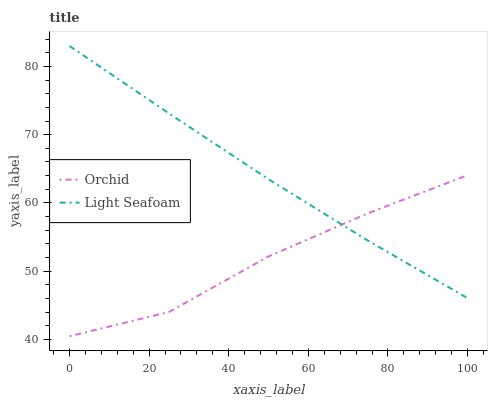Does Orchid have the minimum area under the curve?
Answer yes or no. Yes. Does Light Seafoam have the maximum area under the curve?
Answer yes or no. Yes. Does Orchid have the maximum area under the curve?
Answer yes or no. No. Is Light Seafoam the smoothest?
Answer yes or no. Yes. Is Orchid the roughest?
Answer yes or no. Yes. Is Orchid the smoothest?
Answer yes or no. No. Does Orchid have the lowest value?
Answer yes or no. Yes. Does Light Seafoam have the highest value?
Answer yes or no. Yes. Does Orchid have the highest value?
Answer yes or no. No. Does Orchid intersect Light Seafoam?
Answer yes or no. Yes. Is Orchid less than Light Seafoam?
Answer yes or no. No. Is Orchid greater than Light Seafoam?
Answer yes or no. No. 